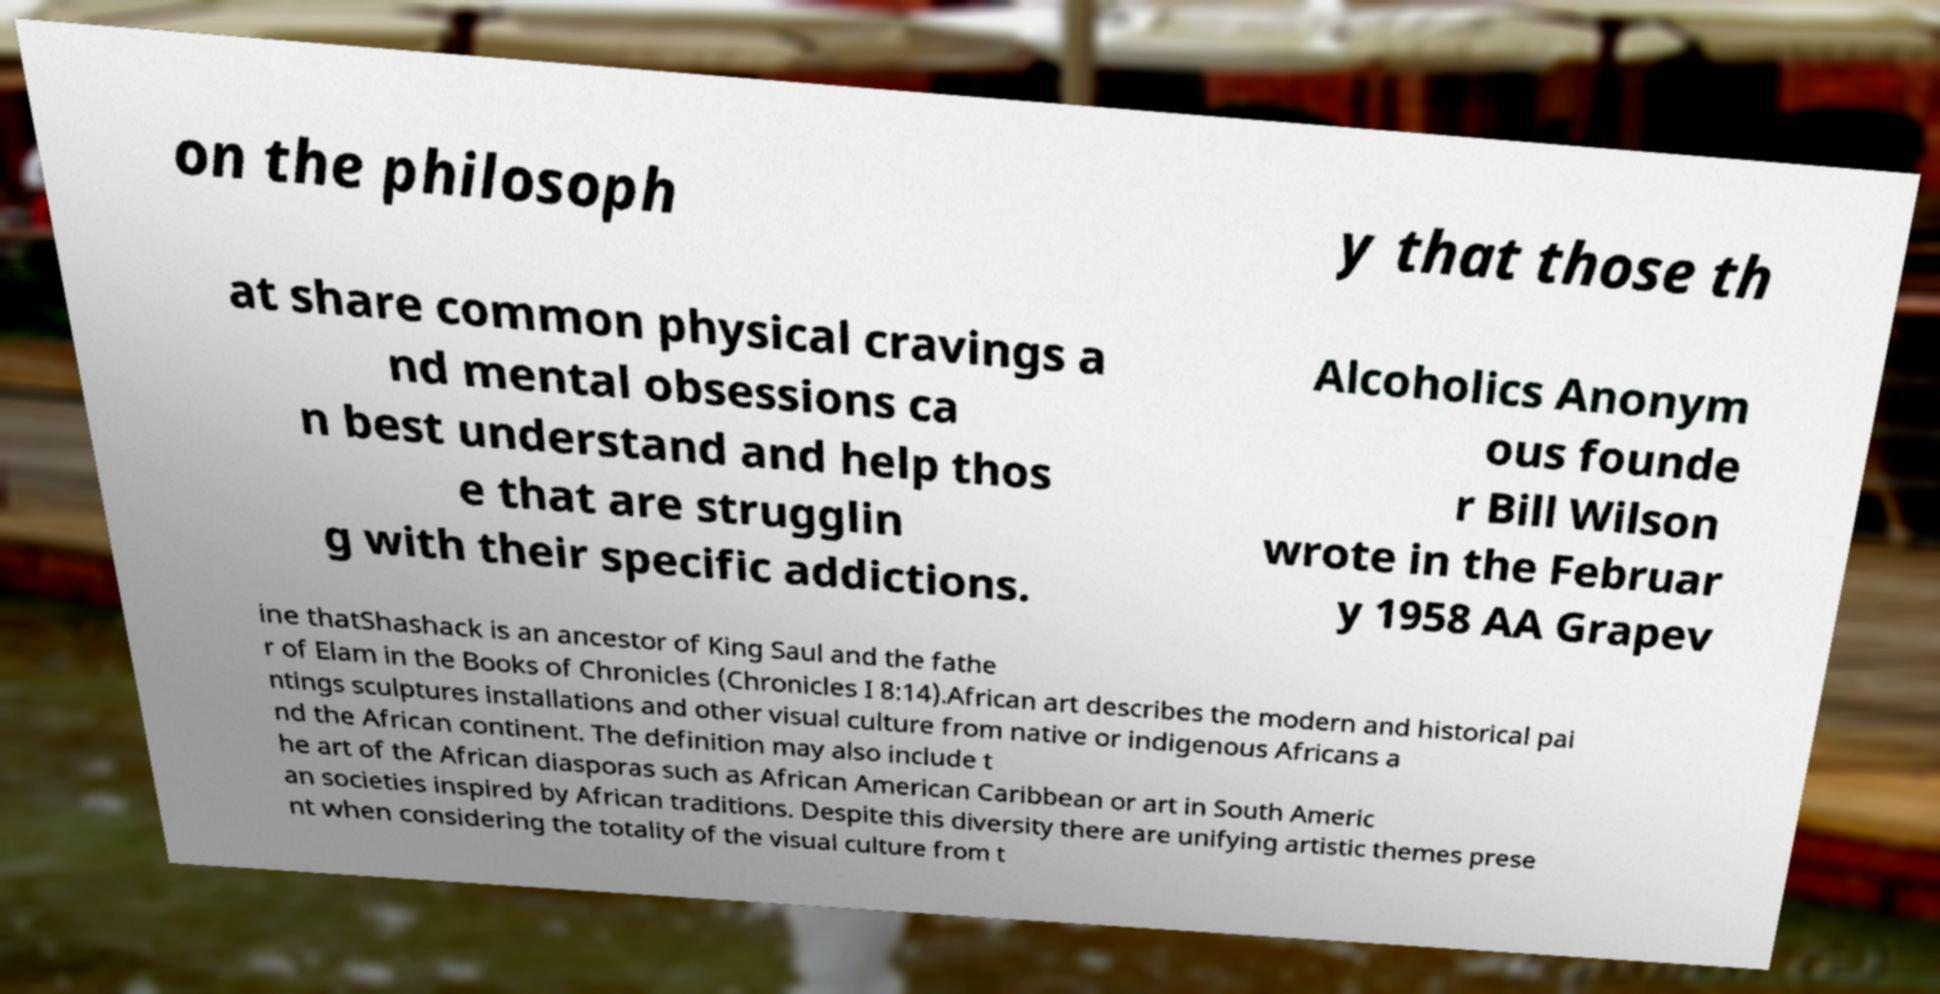Please read and relay the text visible in this image. What does it say? on the philosoph y that those th at share common physical cravings a nd mental obsessions ca n best understand and help thos e that are strugglin g with their specific addictions. Alcoholics Anonym ous founde r Bill Wilson wrote in the Februar y 1958 AA Grapev ine thatShashack is an ancestor of King Saul and the fathe r of Elam in the Books of Chronicles (Chronicles I 8:14).African art describes the modern and historical pai ntings sculptures installations and other visual culture from native or indigenous Africans a nd the African continent. The definition may also include t he art of the African diasporas such as African American Caribbean or art in South Americ an societies inspired by African traditions. Despite this diversity there are unifying artistic themes prese nt when considering the totality of the visual culture from t 